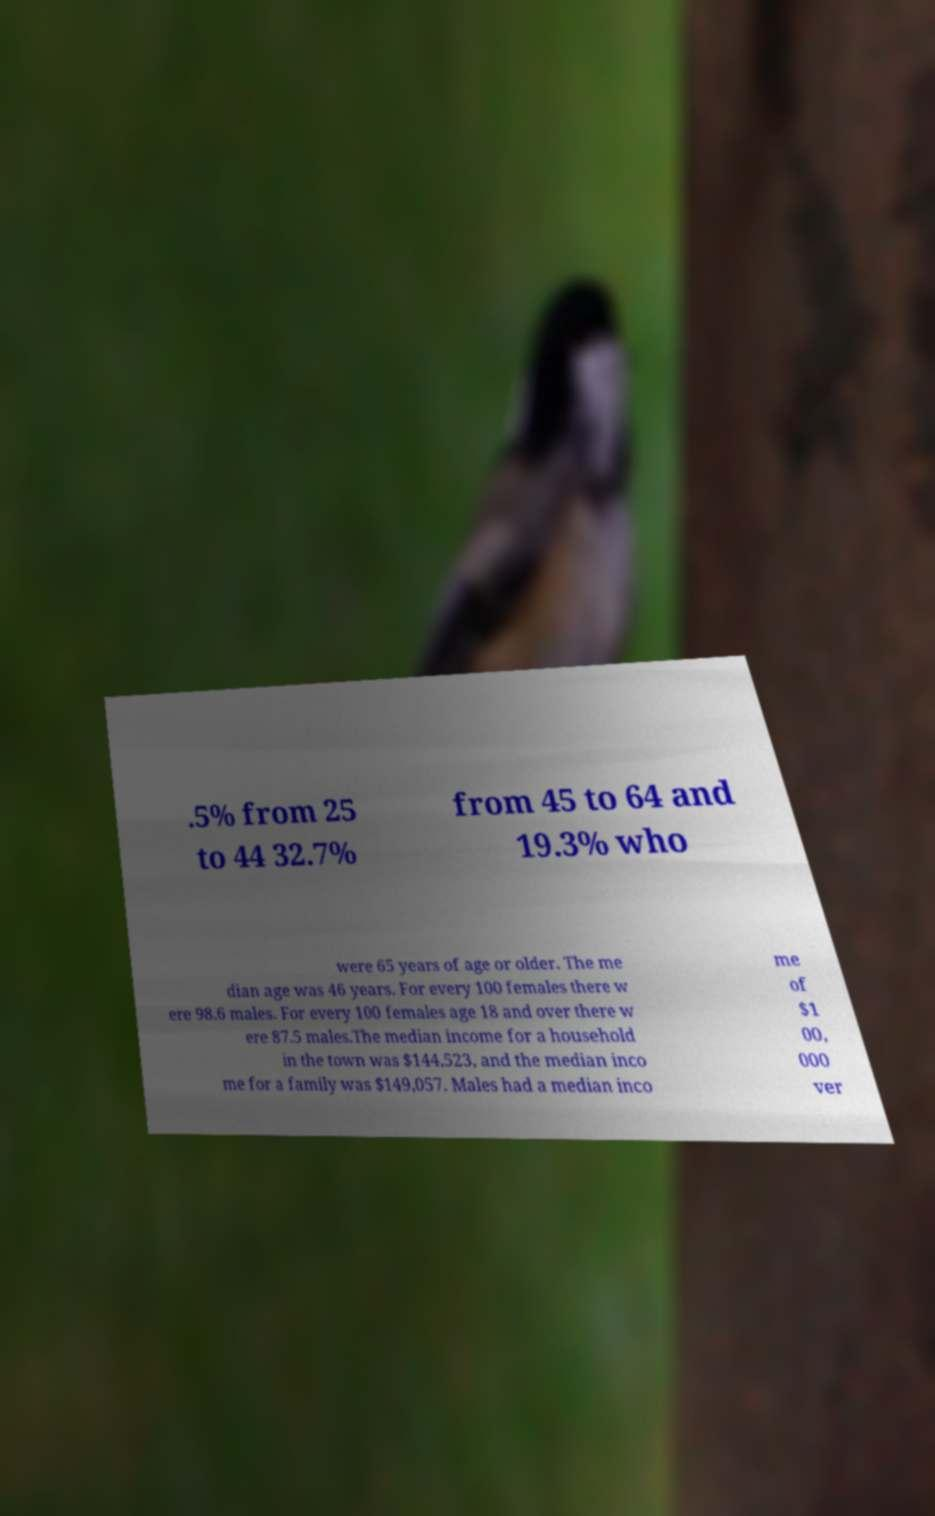I need the written content from this picture converted into text. Can you do that? .5% from 25 to 44 32.7% from 45 to 64 and 19.3% who were 65 years of age or older. The me dian age was 46 years. For every 100 females there w ere 98.6 males. For every 100 females age 18 and over there w ere 87.5 males.The median income for a household in the town was $144,523, and the median inco me for a family was $149,057. Males had a median inco me of $1 00, 000 ver 